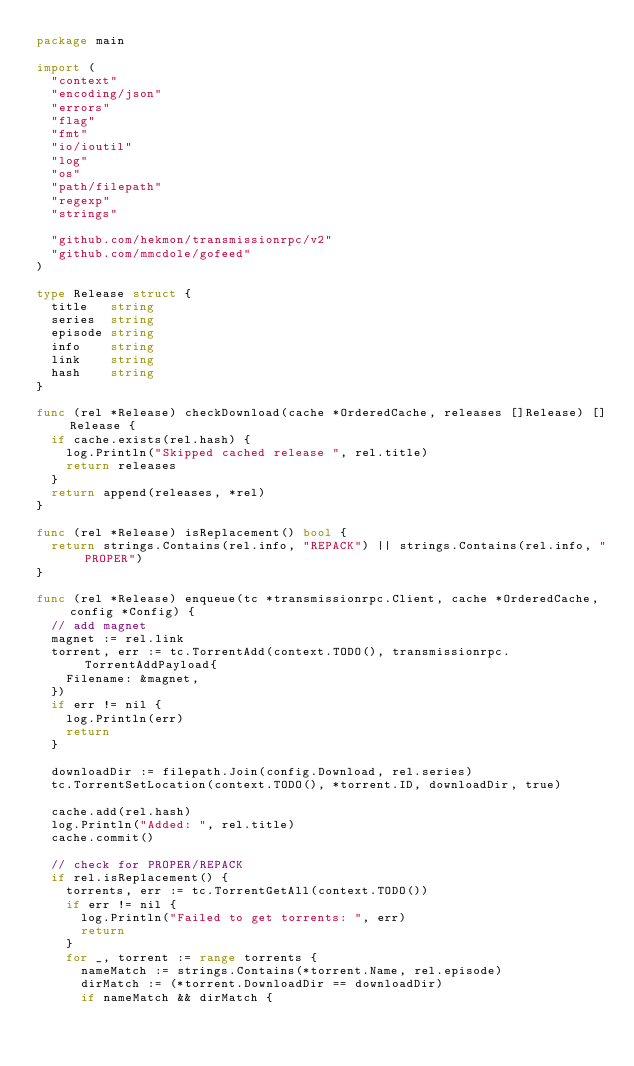<code> <loc_0><loc_0><loc_500><loc_500><_Go_>package main

import (
	"context"
	"encoding/json"
	"errors"
	"flag"
	"fmt"
	"io/ioutil"
	"log"
	"os"
	"path/filepath"
	"regexp"
	"strings"

	"github.com/hekmon/transmissionrpc/v2"
	"github.com/mmcdole/gofeed"
)

type Release struct {
	title   string
	series  string
	episode string
	info    string
	link    string
	hash    string
}

func (rel *Release) checkDownload(cache *OrderedCache, releases []Release) []Release {
	if cache.exists(rel.hash) {
		log.Println("Skipped cached release ", rel.title)
		return releases
	}
	return append(releases, *rel)
}

func (rel *Release) isReplacement() bool {
	return strings.Contains(rel.info, "REPACK") || strings.Contains(rel.info, "PROPER")
}

func (rel *Release) enqueue(tc *transmissionrpc.Client, cache *OrderedCache, config *Config) {
	// add magnet
	magnet := rel.link
	torrent, err := tc.TorrentAdd(context.TODO(), transmissionrpc.TorrentAddPayload{
		Filename: &magnet,
	})
	if err != nil {
		log.Println(err)
		return
	}

	downloadDir := filepath.Join(config.Download, rel.series)
	tc.TorrentSetLocation(context.TODO(), *torrent.ID, downloadDir, true)

	cache.add(rel.hash)
	log.Println("Added: ", rel.title)
	cache.commit()

	// check for PROPER/REPACK
	if rel.isReplacement() {
		torrents, err := tc.TorrentGetAll(context.TODO())
		if err != nil {
			log.Println("Failed to get torrents: ", err)
			return
		}
		for _, torrent := range torrents {
			nameMatch := strings.Contains(*torrent.Name, rel.episode)
			dirMatch := (*torrent.DownloadDir == downloadDir)
			if nameMatch && dirMatch {</code> 